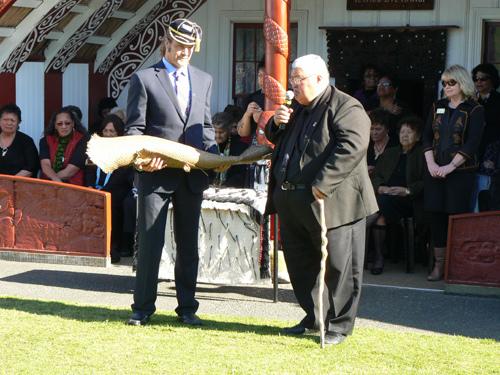What is the stick for?
Keep it brief. Walking. What's in shorter man's left hand?
Concise answer only. Cane. How many dogs are in this photo?
Write a very short answer. 0. 